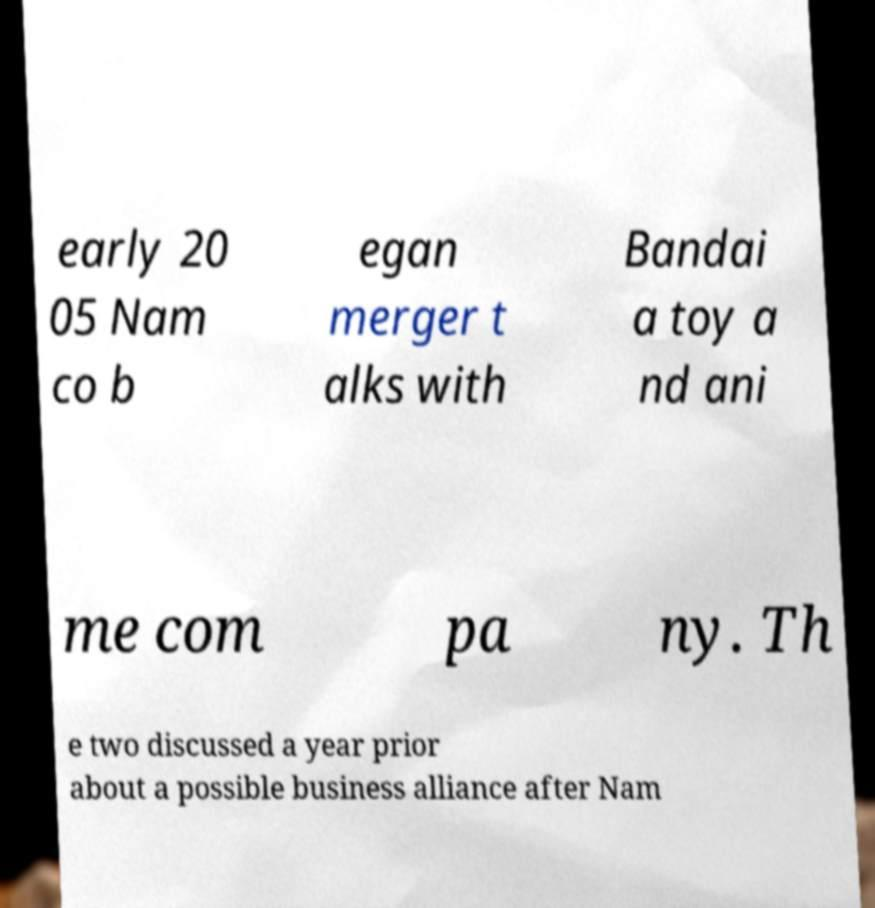Could you extract and type out the text from this image? early 20 05 Nam co b egan merger t alks with Bandai a toy a nd ani me com pa ny. Th e two discussed a year prior about a possible business alliance after Nam 